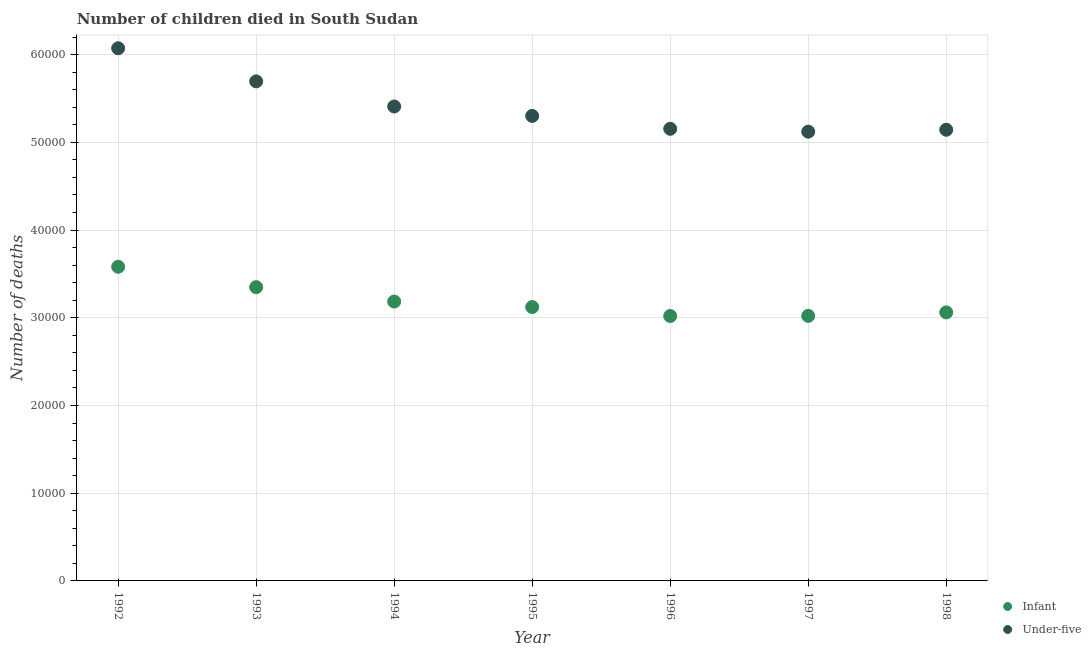What is the number of infant deaths in 1997?
Offer a very short reply. 3.02e+04. Across all years, what is the maximum number of under-five deaths?
Give a very brief answer. 6.07e+04. Across all years, what is the minimum number of infant deaths?
Make the answer very short. 3.02e+04. In which year was the number of infant deaths maximum?
Make the answer very short. 1992. In which year was the number of under-five deaths minimum?
Make the answer very short. 1997. What is the total number of under-five deaths in the graph?
Your answer should be very brief. 3.79e+05. What is the difference between the number of under-five deaths in 1992 and that in 1996?
Offer a very short reply. 9179. What is the difference between the number of infant deaths in 1994 and the number of under-five deaths in 1992?
Your answer should be very brief. -2.89e+04. What is the average number of under-five deaths per year?
Your answer should be very brief. 5.41e+04. In the year 1997, what is the difference between the number of infant deaths and number of under-five deaths?
Provide a succinct answer. -2.10e+04. In how many years, is the number of under-five deaths greater than 6000?
Provide a short and direct response. 7. What is the ratio of the number of infant deaths in 1992 to that in 1993?
Give a very brief answer. 1.07. What is the difference between the highest and the second highest number of under-five deaths?
Make the answer very short. 3774. What is the difference between the highest and the lowest number of infant deaths?
Provide a short and direct response. 5609. In how many years, is the number of infant deaths greater than the average number of infant deaths taken over all years?
Your response must be concise. 2. Is the sum of the number of infant deaths in 1994 and 1995 greater than the maximum number of under-five deaths across all years?
Offer a terse response. Yes. Does the number of under-five deaths monotonically increase over the years?
Ensure brevity in your answer.  No. How many years are there in the graph?
Your answer should be compact. 7. What is the difference between two consecutive major ticks on the Y-axis?
Offer a terse response. 10000. Does the graph contain any zero values?
Offer a very short reply. No. Does the graph contain grids?
Your response must be concise. Yes. Where does the legend appear in the graph?
Make the answer very short. Bottom right. How many legend labels are there?
Keep it short and to the point. 2. How are the legend labels stacked?
Provide a short and direct response. Vertical. What is the title of the graph?
Make the answer very short. Number of children died in South Sudan. Does "Fixed telephone" appear as one of the legend labels in the graph?
Offer a very short reply. No. What is the label or title of the X-axis?
Your response must be concise. Year. What is the label or title of the Y-axis?
Provide a short and direct response. Number of deaths. What is the Number of deaths of Infant in 1992?
Provide a succinct answer. 3.58e+04. What is the Number of deaths of Under-five in 1992?
Your response must be concise. 6.07e+04. What is the Number of deaths of Infant in 1993?
Make the answer very short. 3.35e+04. What is the Number of deaths in Under-five in 1993?
Give a very brief answer. 5.69e+04. What is the Number of deaths of Infant in 1994?
Ensure brevity in your answer.  3.18e+04. What is the Number of deaths in Under-five in 1994?
Your answer should be compact. 5.41e+04. What is the Number of deaths of Infant in 1995?
Keep it short and to the point. 3.12e+04. What is the Number of deaths of Under-five in 1995?
Make the answer very short. 5.30e+04. What is the Number of deaths of Infant in 1996?
Provide a short and direct response. 3.02e+04. What is the Number of deaths in Under-five in 1996?
Your answer should be compact. 5.15e+04. What is the Number of deaths in Infant in 1997?
Offer a very short reply. 3.02e+04. What is the Number of deaths in Under-five in 1997?
Offer a terse response. 5.12e+04. What is the Number of deaths in Infant in 1998?
Provide a succinct answer. 3.06e+04. What is the Number of deaths of Under-five in 1998?
Provide a short and direct response. 5.14e+04. Across all years, what is the maximum Number of deaths in Infant?
Your answer should be very brief. 3.58e+04. Across all years, what is the maximum Number of deaths of Under-five?
Give a very brief answer. 6.07e+04. Across all years, what is the minimum Number of deaths of Infant?
Your response must be concise. 3.02e+04. Across all years, what is the minimum Number of deaths in Under-five?
Ensure brevity in your answer.  5.12e+04. What is the total Number of deaths in Infant in the graph?
Keep it short and to the point. 2.23e+05. What is the total Number of deaths in Under-five in the graph?
Give a very brief answer. 3.79e+05. What is the difference between the Number of deaths in Infant in 1992 and that in 1993?
Provide a succinct answer. 2322. What is the difference between the Number of deaths in Under-five in 1992 and that in 1993?
Your answer should be compact. 3774. What is the difference between the Number of deaths in Infant in 1992 and that in 1994?
Provide a short and direct response. 3963. What is the difference between the Number of deaths of Under-five in 1992 and that in 1994?
Make the answer very short. 6637. What is the difference between the Number of deaths in Infant in 1992 and that in 1995?
Your answer should be very brief. 4590. What is the difference between the Number of deaths in Under-five in 1992 and that in 1995?
Provide a short and direct response. 7712. What is the difference between the Number of deaths in Infant in 1992 and that in 1996?
Keep it short and to the point. 5609. What is the difference between the Number of deaths of Under-five in 1992 and that in 1996?
Ensure brevity in your answer.  9179. What is the difference between the Number of deaths in Infant in 1992 and that in 1997?
Provide a short and direct response. 5594. What is the difference between the Number of deaths in Under-five in 1992 and that in 1997?
Your answer should be compact. 9506. What is the difference between the Number of deaths of Infant in 1992 and that in 1998?
Provide a succinct answer. 5199. What is the difference between the Number of deaths of Under-five in 1992 and that in 1998?
Your answer should be very brief. 9289. What is the difference between the Number of deaths of Infant in 1993 and that in 1994?
Offer a very short reply. 1641. What is the difference between the Number of deaths in Under-five in 1993 and that in 1994?
Keep it short and to the point. 2863. What is the difference between the Number of deaths in Infant in 1993 and that in 1995?
Your response must be concise. 2268. What is the difference between the Number of deaths in Under-five in 1993 and that in 1995?
Provide a succinct answer. 3938. What is the difference between the Number of deaths of Infant in 1993 and that in 1996?
Provide a succinct answer. 3287. What is the difference between the Number of deaths of Under-five in 1993 and that in 1996?
Your answer should be compact. 5405. What is the difference between the Number of deaths in Infant in 1993 and that in 1997?
Your answer should be very brief. 3272. What is the difference between the Number of deaths of Under-five in 1993 and that in 1997?
Offer a terse response. 5732. What is the difference between the Number of deaths in Infant in 1993 and that in 1998?
Provide a short and direct response. 2877. What is the difference between the Number of deaths in Under-five in 1993 and that in 1998?
Provide a short and direct response. 5515. What is the difference between the Number of deaths of Infant in 1994 and that in 1995?
Ensure brevity in your answer.  627. What is the difference between the Number of deaths of Under-five in 1994 and that in 1995?
Offer a terse response. 1075. What is the difference between the Number of deaths in Infant in 1994 and that in 1996?
Keep it short and to the point. 1646. What is the difference between the Number of deaths in Under-five in 1994 and that in 1996?
Ensure brevity in your answer.  2542. What is the difference between the Number of deaths in Infant in 1994 and that in 1997?
Provide a succinct answer. 1631. What is the difference between the Number of deaths in Under-five in 1994 and that in 1997?
Provide a succinct answer. 2869. What is the difference between the Number of deaths in Infant in 1994 and that in 1998?
Offer a very short reply. 1236. What is the difference between the Number of deaths of Under-five in 1994 and that in 1998?
Offer a very short reply. 2652. What is the difference between the Number of deaths in Infant in 1995 and that in 1996?
Keep it short and to the point. 1019. What is the difference between the Number of deaths of Under-five in 1995 and that in 1996?
Your answer should be compact. 1467. What is the difference between the Number of deaths of Infant in 1995 and that in 1997?
Your answer should be compact. 1004. What is the difference between the Number of deaths of Under-five in 1995 and that in 1997?
Give a very brief answer. 1794. What is the difference between the Number of deaths of Infant in 1995 and that in 1998?
Your response must be concise. 609. What is the difference between the Number of deaths in Under-five in 1995 and that in 1998?
Keep it short and to the point. 1577. What is the difference between the Number of deaths in Under-five in 1996 and that in 1997?
Ensure brevity in your answer.  327. What is the difference between the Number of deaths of Infant in 1996 and that in 1998?
Offer a terse response. -410. What is the difference between the Number of deaths in Under-five in 1996 and that in 1998?
Provide a short and direct response. 110. What is the difference between the Number of deaths of Infant in 1997 and that in 1998?
Offer a very short reply. -395. What is the difference between the Number of deaths of Under-five in 1997 and that in 1998?
Your answer should be compact. -217. What is the difference between the Number of deaths of Infant in 1992 and the Number of deaths of Under-five in 1993?
Offer a very short reply. -2.11e+04. What is the difference between the Number of deaths in Infant in 1992 and the Number of deaths in Under-five in 1994?
Offer a terse response. -1.83e+04. What is the difference between the Number of deaths in Infant in 1992 and the Number of deaths in Under-five in 1995?
Provide a short and direct response. -1.72e+04. What is the difference between the Number of deaths of Infant in 1992 and the Number of deaths of Under-five in 1996?
Your response must be concise. -1.57e+04. What is the difference between the Number of deaths of Infant in 1992 and the Number of deaths of Under-five in 1997?
Make the answer very short. -1.54e+04. What is the difference between the Number of deaths in Infant in 1992 and the Number of deaths in Under-five in 1998?
Ensure brevity in your answer.  -1.56e+04. What is the difference between the Number of deaths of Infant in 1993 and the Number of deaths of Under-five in 1994?
Give a very brief answer. -2.06e+04. What is the difference between the Number of deaths of Infant in 1993 and the Number of deaths of Under-five in 1995?
Offer a very short reply. -1.95e+04. What is the difference between the Number of deaths in Infant in 1993 and the Number of deaths in Under-five in 1996?
Provide a short and direct response. -1.81e+04. What is the difference between the Number of deaths in Infant in 1993 and the Number of deaths in Under-five in 1997?
Your answer should be very brief. -1.77e+04. What is the difference between the Number of deaths of Infant in 1993 and the Number of deaths of Under-five in 1998?
Make the answer very short. -1.79e+04. What is the difference between the Number of deaths of Infant in 1994 and the Number of deaths of Under-five in 1995?
Your response must be concise. -2.12e+04. What is the difference between the Number of deaths in Infant in 1994 and the Number of deaths in Under-five in 1996?
Make the answer very short. -1.97e+04. What is the difference between the Number of deaths in Infant in 1994 and the Number of deaths in Under-five in 1997?
Give a very brief answer. -1.94e+04. What is the difference between the Number of deaths in Infant in 1994 and the Number of deaths in Under-five in 1998?
Your response must be concise. -1.96e+04. What is the difference between the Number of deaths of Infant in 1995 and the Number of deaths of Under-five in 1996?
Your answer should be compact. -2.03e+04. What is the difference between the Number of deaths in Infant in 1995 and the Number of deaths in Under-five in 1997?
Your response must be concise. -2.00e+04. What is the difference between the Number of deaths in Infant in 1995 and the Number of deaths in Under-five in 1998?
Your response must be concise. -2.02e+04. What is the difference between the Number of deaths of Infant in 1996 and the Number of deaths of Under-five in 1997?
Make the answer very short. -2.10e+04. What is the difference between the Number of deaths of Infant in 1996 and the Number of deaths of Under-five in 1998?
Provide a succinct answer. -2.12e+04. What is the difference between the Number of deaths of Infant in 1997 and the Number of deaths of Under-five in 1998?
Your answer should be very brief. -2.12e+04. What is the average Number of deaths of Infant per year?
Offer a terse response. 3.19e+04. What is the average Number of deaths of Under-five per year?
Make the answer very short. 5.41e+04. In the year 1992, what is the difference between the Number of deaths in Infant and Number of deaths in Under-five?
Your response must be concise. -2.49e+04. In the year 1993, what is the difference between the Number of deaths in Infant and Number of deaths in Under-five?
Provide a short and direct response. -2.35e+04. In the year 1994, what is the difference between the Number of deaths in Infant and Number of deaths in Under-five?
Make the answer very short. -2.22e+04. In the year 1995, what is the difference between the Number of deaths of Infant and Number of deaths of Under-five?
Offer a terse response. -2.18e+04. In the year 1996, what is the difference between the Number of deaths of Infant and Number of deaths of Under-five?
Give a very brief answer. -2.13e+04. In the year 1997, what is the difference between the Number of deaths in Infant and Number of deaths in Under-five?
Make the answer very short. -2.10e+04. In the year 1998, what is the difference between the Number of deaths of Infant and Number of deaths of Under-five?
Make the answer very short. -2.08e+04. What is the ratio of the Number of deaths in Infant in 1992 to that in 1993?
Provide a succinct answer. 1.07. What is the ratio of the Number of deaths of Under-five in 1992 to that in 1993?
Provide a succinct answer. 1.07. What is the ratio of the Number of deaths of Infant in 1992 to that in 1994?
Provide a succinct answer. 1.12. What is the ratio of the Number of deaths of Under-five in 1992 to that in 1994?
Keep it short and to the point. 1.12. What is the ratio of the Number of deaths in Infant in 1992 to that in 1995?
Your answer should be very brief. 1.15. What is the ratio of the Number of deaths in Under-five in 1992 to that in 1995?
Provide a succinct answer. 1.15. What is the ratio of the Number of deaths of Infant in 1992 to that in 1996?
Ensure brevity in your answer.  1.19. What is the ratio of the Number of deaths in Under-five in 1992 to that in 1996?
Provide a succinct answer. 1.18. What is the ratio of the Number of deaths of Infant in 1992 to that in 1997?
Your response must be concise. 1.19. What is the ratio of the Number of deaths in Under-five in 1992 to that in 1997?
Ensure brevity in your answer.  1.19. What is the ratio of the Number of deaths in Infant in 1992 to that in 1998?
Provide a succinct answer. 1.17. What is the ratio of the Number of deaths in Under-five in 1992 to that in 1998?
Keep it short and to the point. 1.18. What is the ratio of the Number of deaths in Infant in 1993 to that in 1994?
Provide a short and direct response. 1.05. What is the ratio of the Number of deaths of Under-five in 1993 to that in 1994?
Your answer should be very brief. 1.05. What is the ratio of the Number of deaths of Infant in 1993 to that in 1995?
Make the answer very short. 1.07. What is the ratio of the Number of deaths of Under-five in 1993 to that in 1995?
Offer a very short reply. 1.07. What is the ratio of the Number of deaths in Infant in 1993 to that in 1996?
Provide a short and direct response. 1.11. What is the ratio of the Number of deaths of Under-five in 1993 to that in 1996?
Offer a terse response. 1.1. What is the ratio of the Number of deaths in Infant in 1993 to that in 1997?
Keep it short and to the point. 1.11. What is the ratio of the Number of deaths in Under-five in 1993 to that in 1997?
Provide a succinct answer. 1.11. What is the ratio of the Number of deaths of Infant in 1993 to that in 1998?
Ensure brevity in your answer.  1.09. What is the ratio of the Number of deaths in Under-five in 1993 to that in 1998?
Ensure brevity in your answer.  1.11. What is the ratio of the Number of deaths in Infant in 1994 to that in 1995?
Your answer should be very brief. 1.02. What is the ratio of the Number of deaths of Under-five in 1994 to that in 1995?
Offer a terse response. 1.02. What is the ratio of the Number of deaths of Infant in 1994 to that in 1996?
Make the answer very short. 1.05. What is the ratio of the Number of deaths of Under-five in 1994 to that in 1996?
Offer a very short reply. 1.05. What is the ratio of the Number of deaths of Infant in 1994 to that in 1997?
Offer a very short reply. 1.05. What is the ratio of the Number of deaths in Under-five in 1994 to that in 1997?
Your answer should be very brief. 1.06. What is the ratio of the Number of deaths of Infant in 1994 to that in 1998?
Your response must be concise. 1.04. What is the ratio of the Number of deaths of Under-five in 1994 to that in 1998?
Ensure brevity in your answer.  1.05. What is the ratio of the Number of deaths in Infant in 1995 to that in 1996?
Ensure brevity in your answer.  1.03. What is the ratio of the Number of deaths in Under-five in 1995 to that in 1996?
Your answer should be compact. 1.03. What is the ratio of the Number of deaths in Infant in 1995 to that in 1997?
Offer a terse response. 1.03. What is the ratio of the Number of deaths of Under-five in 1995 to that in 1997?
Provide a short and direct response. 1.03. What is the ratio of the Number of deaths of Infant in 1995 to that in 1998?
Make the answer very short. 1.02. What is the ratio of the Number of deaths in Under-five in 1995 to that in 1998?
Offer a terse response. 1.03. What is the ratio of the Number of deaths in Under-five in 1996 to that in 1997?
Provide a succinct answer. 1.01. What is the ratio of the Number of deaths of Infant in 1996 to that in 1998?
Provide a short and direct response. 0.99. What is the ratio of the Number of deaths of Under-five in 1996 to that in 1998?
Keep it short and to the point. 1. What is the ratio of the Number of deaths of Infant in 1997 to that in 1998?
Keep it short and to the point. 0.99. What is the difference between the highest and the second highest Number of deaths in Infant?
Make the answer very short. 2322. What is the difference between the highest and the second highest Number of deaths in Under-five?
Ensure brevity in your answer.  3774. What is the difference between the highest and the lowest Number of deaths of Infant?
Offer a very short reply. 5609. What is the difference between the highest and the lowest Number of deaths in Under-five?
Ensure brevity in your answer.  9506. 